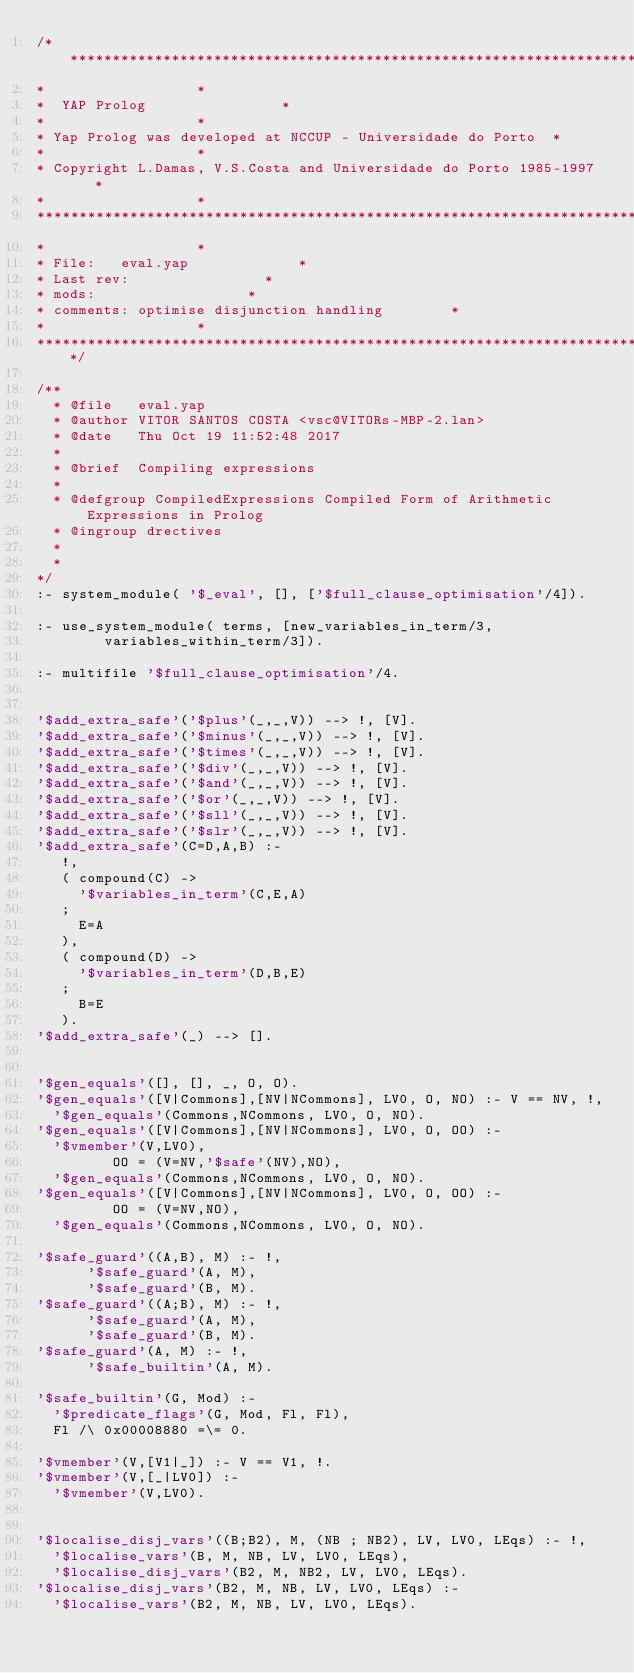<code> <loc_0><loc_0><loc_500><loc_500><_Prolog_>/*************************************************************************
*									 *
*	 YAP Prolog 							 *
*									 *
*	Yap Prolog was developed at NCCUP - Universidade do Porto	 *
*									 *
* Copyright L.Damas, V.S.Costa and Universidade do Porto 1985-1997	 *
*									 *
**************************************************************************
*									 *
* File:		eval.yap						 *
* Last rev:								 *
* mods:									 *
* comments:	optimise disjunction handling				 *
*									 *
*************************************************************************/

/**
  * @file   eval.yap
  * @author VITOR SANTOS COSTA <vsc@VITORs-MBP-2.lan>
  * @date   Thu Oct 19 11:52:48 2017
  * 
  * @brief  Compiling expressions
  *
  * @defgroup CompiledExpressions Compiled Form of Arithmetic Expressions in Prolog
  * @ingroup drectives
  * 
  * 
*/
:- system_module( '$_eval', [], ['$full_clause_optimisation'/4]).

:- use_system_module( terms, [new_variables_in_term/3,
        variables_within_term/3]).

:- multifile '$full_clause_optimisation'/4.


'$add_extra_safe'('$plus'(_,_,V)) --> !, [V].
'$add_extra_safe'('$minus'(_,_,V)) --> !, [V].
'$add_extra_safe'('$times'(_,_,V)) --> !, [V].
'$add_extra_safe'('$div'(_,_,V)) --> !, [V].
'$add_extra_safe'('$and'(_,_,V)) --> !, [V].
'$add_extra_safe'('$or'(_,_,V)) --> !, [V].
'$add_extra_safe'('$sll'(_,_,V)) --> !, [V].
'$add_extra_safe'('$slr'(_,_,V)) --> !, [V].
'$add_extra_safe'(C=D,A,B) :-
   !,
   ( compound(C) ->
     '$variables_in_term'(C,E,A)
   ;
     E=A
   ),
   ( compound(D) ->
     '$variables_in_term'(D,B,E)
   ;
     B=E
   ).
'$add_extra_safe'(_) --> [].


'$gen_equals'([], [], _, O, O).
'$gen_equals'([V|Commons],[NV|NCommons], LV0, O, NO) :- V == NV, !,
	'$gen_equals'(Commons,NCommons, LV0, O, NO).
'$gen_equals'([V|Commons],[NV|NCommons], LV0, O, OO) :-
	'$vmember'(V,LV0),
         OO = (V=NV,'$safe'(NV),NO),
	'$gen_equals'(Commons,NCommons, LV0, O, NO).
'$gen_equals'([V|Commons],[NV|NCommons], LV0, O, OO) :-
         OO = (V=NV,NO),
	'$gen_equals'(Commons,NCommons, LV0, O, NO).

'$safe_guard'((A,B), M) :- !,
	    '$safe_guard'(A, M),
	    '$safe_guard'(B, M).
'$safe_guard'((A;B), M) :- !,
	    '$safe_guard'(A, M),
	    '$safe_guard'(B, M).
'$safe_guard'(A, M) :- !,
	    '$safe_builtin'(A, M).

'$safe_builtin'(G, Mod) :-
	'$predicate_flags'(G, Mod, Fl, Fl),
	Fl /\ 0x00008880 =\= 0.

'$vmember'(V,[V1|_]) :- V == V1, !.
'$vmember'(V,[_|LV0]) :-
	'$vmember'(V,LV0).


'$localise_disj_vars'((B;B2), M, (NB ; NB2), LV, LV0, LEqs) :- !,
	'$localise_vars'(B, M, NB, LV, LV0, LEqs),
	'$localise_disj_vars'(B2, M, NB2, LV, LV0, LEqs).
'$localise_disj_vars'(B2, M, NB, LV, LV0, LEqs) :-
	'$localise_vars'(B2, M, NB, LV, LV0, LEqs).
</code> 